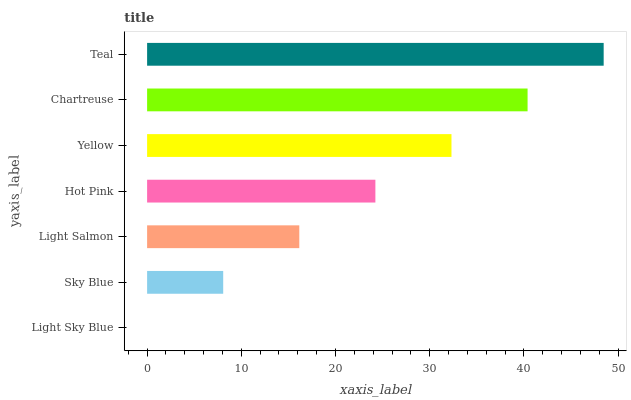Is Light Sky Blue the minimum?
Answer yes or no. Yes. Is Teal the maximum?
Answer yes or no. Yes. Is Sky Blue the minimum?
Answer yes or no. No. Is Sky Blue the maximum?
Answer yes or no. No. Is Sky Blue greater than Light Sky Blue?
Answer yes or no. Yes. Is Light Sky Blue less than Sky Blue?
Answer yes or no. Yes. Is Light Sky Blue greater than Sky Blue?
Answer yes or no. No. Is Sky Blue less than Light Sky Blue?
Answer yes or no. No. Is Hot Pink the high median?
Answer yes or no. Yes. Is Hot Pink the low median?
Answer yes or no. Yes. Is Chartreuse the high median?
Answer yes or no. No. Is Sky Blue the low median?
Answer yes or no. No. 